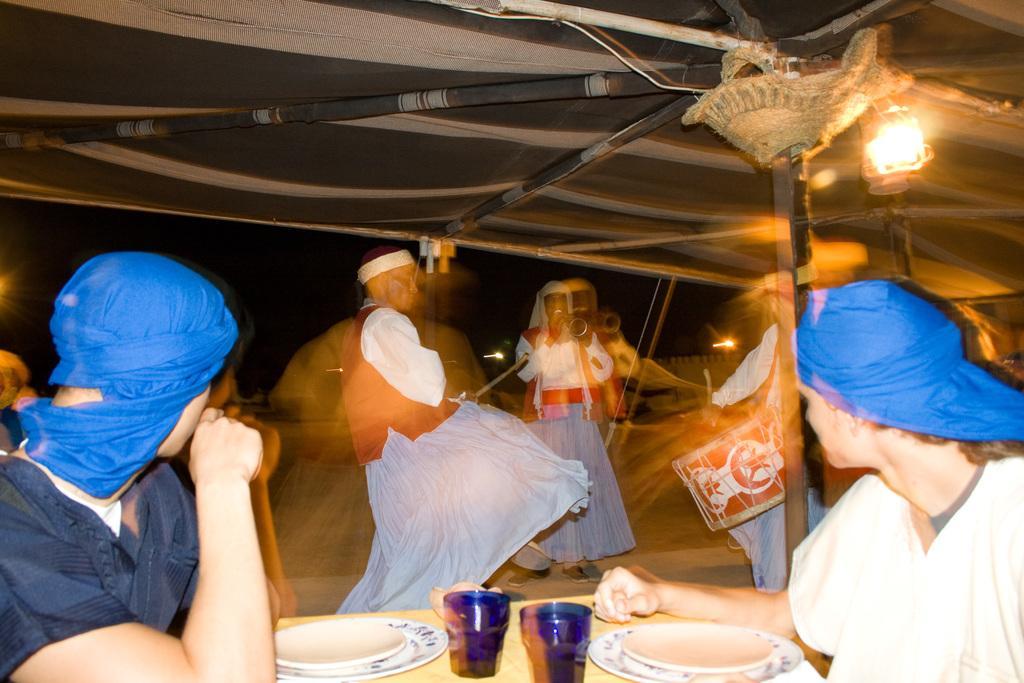Can you describe this image briefly? These two people are playing musical instruments. This person is holding a stick. Under this tent there is a lantern lamp and people. On this table there are glasses and plates. 